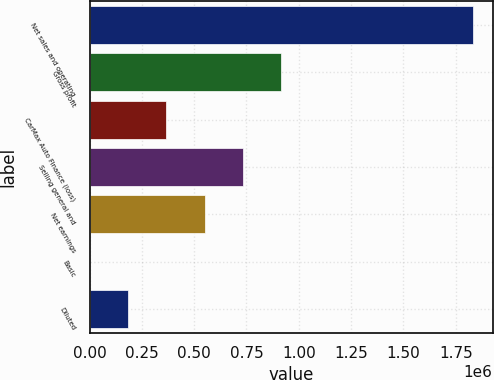Convert chart to OTSL. <chart><loc_0><loc_0><loc_500><loc_500><bar_chart><fcel>Net sales and operating<fcel>Gross profit<fcel>CarMax Auto Finance (loss)<fcel>Selling general and<fcel>Net earnings<fcel>Basic<fcel>Diluted<nl><fcel>1.8343e+06<fcel>917150<fcel>366860<fcel>733720<fcel>550290<fcel>0.13<fcel>183430<nl></chart> 